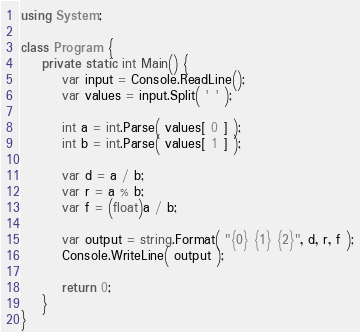Convert code to text. <code><loc_0><loc_0><loc_500><loc_500><_C#_>using System;

class Program {
    private static int Main() {
        var input = Console.ReadLine();
        var values = input.Split( ' ' );

        int a = int.Parse( values[ 0 ] );
        int b = int.Parse( values[ 1 ] );

        var d = a / b;
        var r = a % b;
        var f = (float)a / b;

        var output = string.Format( "{0} {1} {2}", d, r, f );
        Console.WriteLine( output );

        return 0;
    }
}</code> 